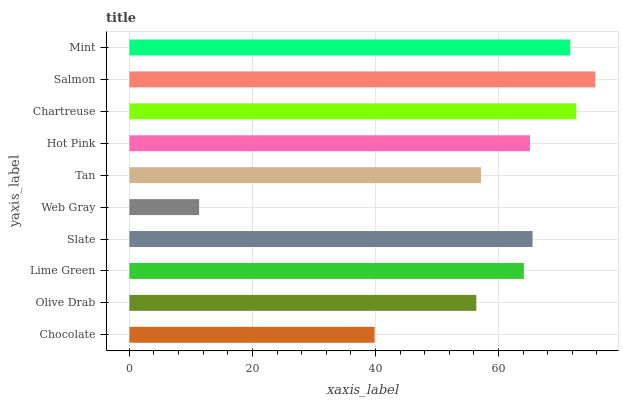Is Web Gray the minimum?
Answer yes or no. Yes. Is Salmon the maximum?
Answer yes or no. Yes. Is Olive Drab the minimum?
Answer yes or no. No. Is Olive Drab the maximum?
Answer yes or no. No. Is Olive Drab greater than Chocolate?
Answer yes or no. Yes. Is Chocolate less than Olive Drab?
Answer yes or no. Yes. Is Chocolate greater than Olive Drab?
Answer yes or no. No. Is Olive Drab less than Chocolate?
Answer yes or no. No. Is Hot Pink the high median?
Answer yes or no. Yes. Is Lime Green the low median?
Answer yes or no. Yes. Is Lime Green the high median?
Answer yes or no. No. Is Olive Drab the low median?
Answer yes or no. No. 